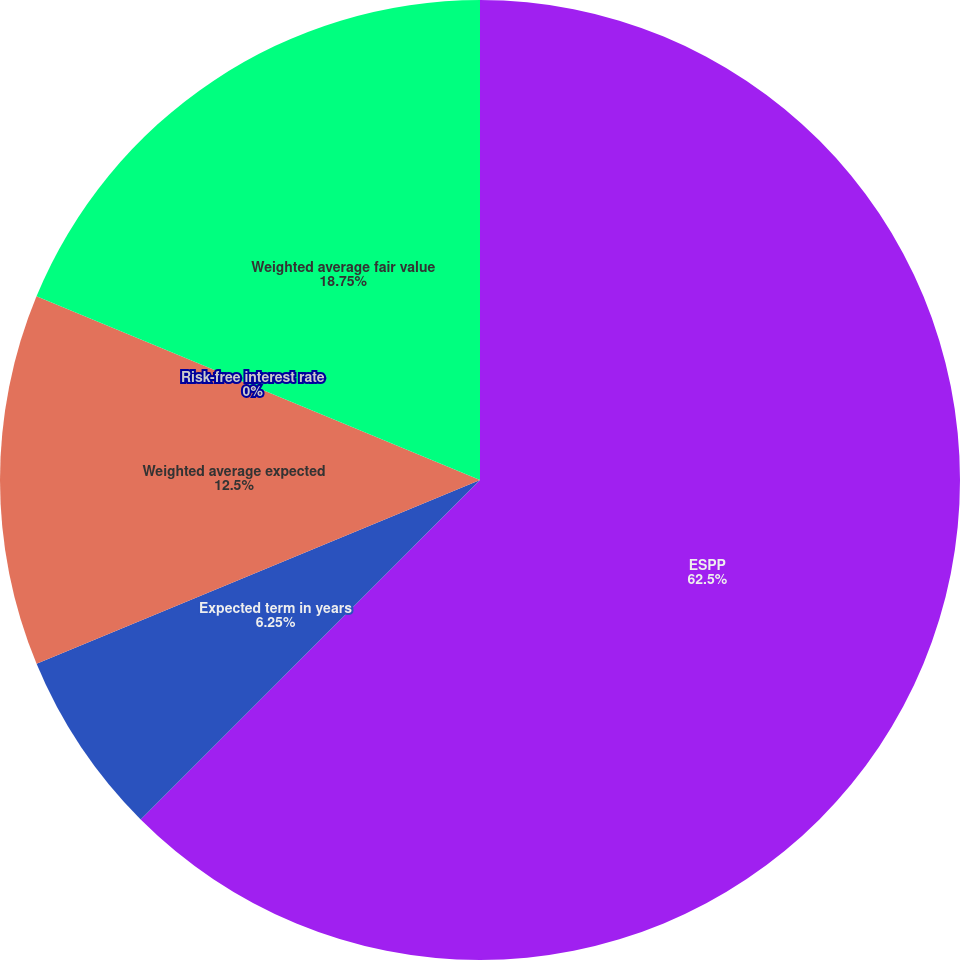<chart> <loc_0><loc_0><loc_500><loc_500><pie_chart><fcel>ESPP<fcel>Expected term in years<fcel>Weighted average expected<fcel>Risk-free interest rate<fcel>Weighted average fair value<nl><fcel>62.49%<fcel>6.25%<fcel>12.5%<fcel>0.0%<fcel>18.75%<nl></chart> 